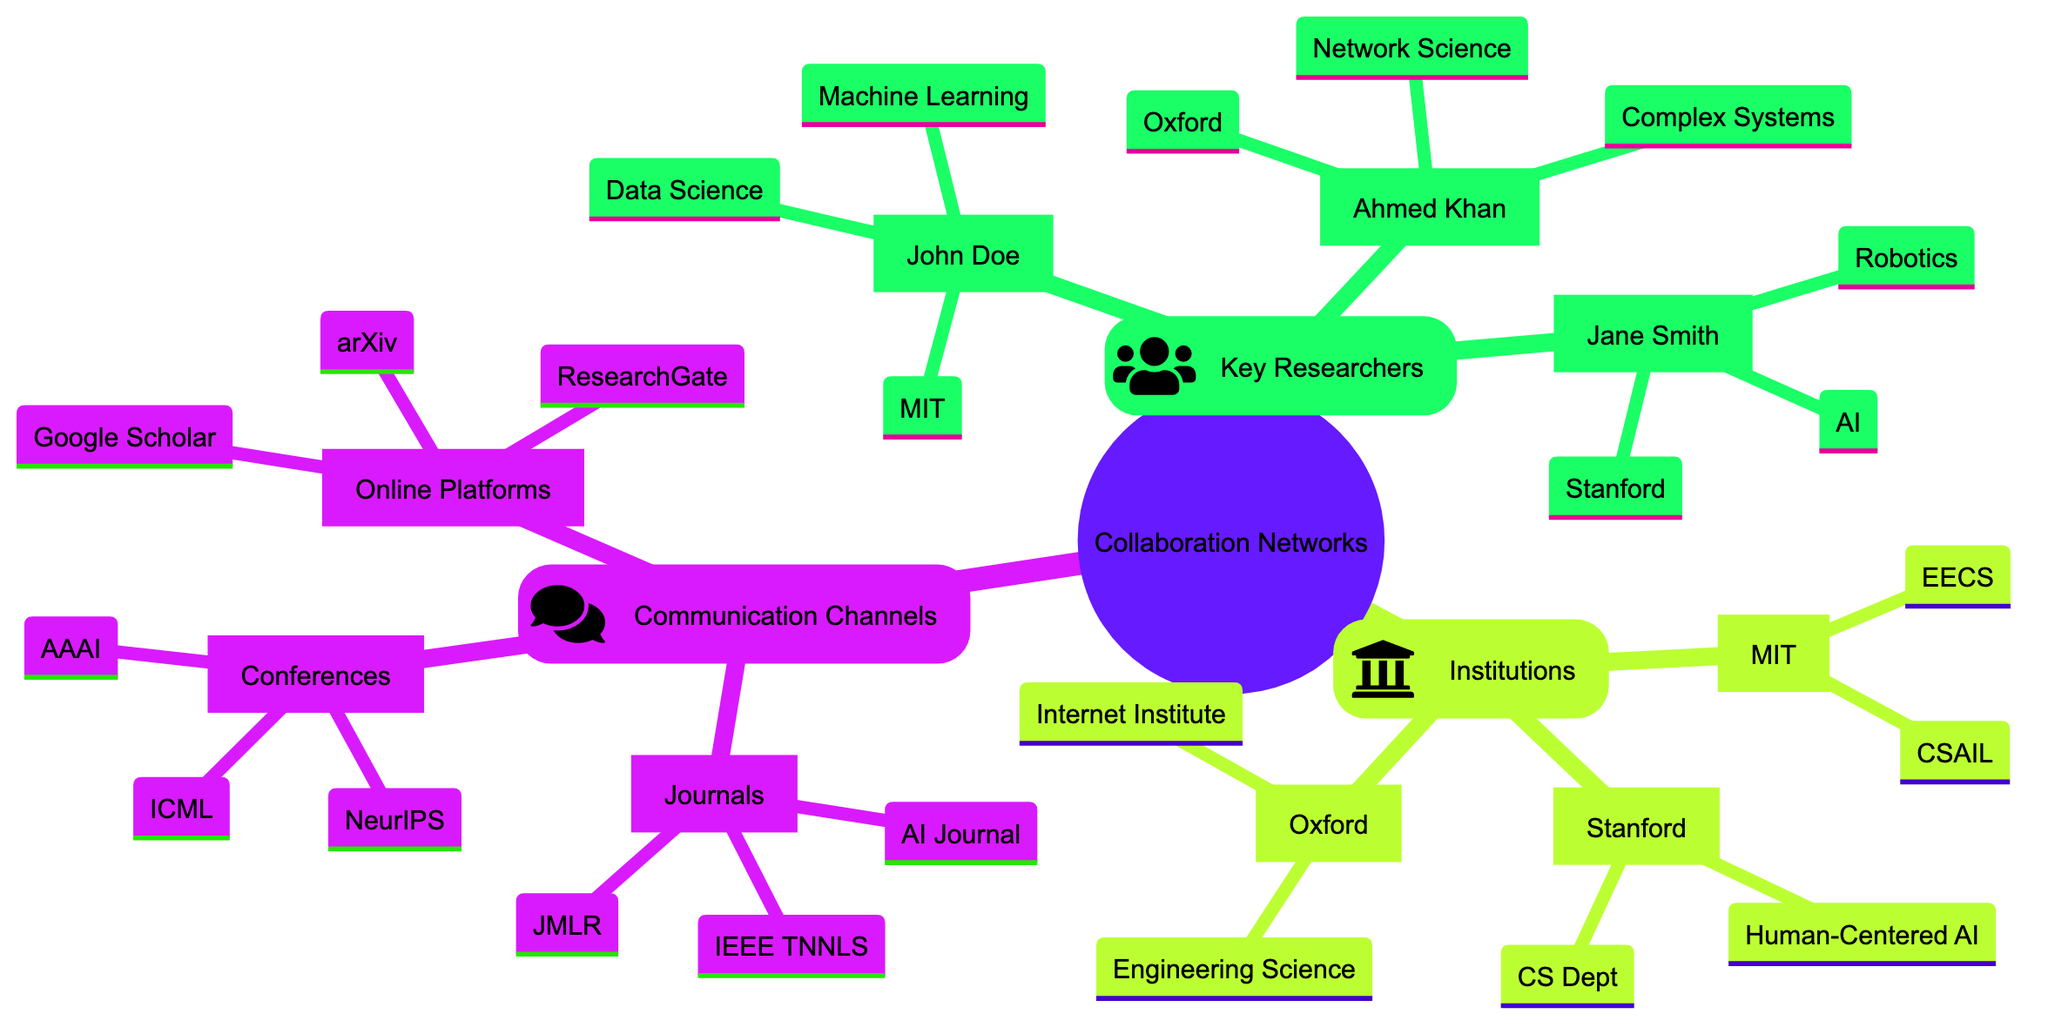What is the institution of John Doe? By looking at the "Key Researchers" section of the diagram, I can see that John Doe is associated with the Massachusetts Institute of Technology, which is listed directly under his name.
Answer: Massachusetts Institute of Technology How many key researchers are listed in the diagram? I can count the names listed under the "Key Researchers" section. There are three names: John Doe, Jane Smith, and Ahmed Khan. Therefore, the total number of key researchers is three.
Answer: 3 What are the research areas of Jane Smith? To find the research areas for Jane Smith, I look under her name in the "Key Researchers" section. It shows "Artificial Intelligence" and "Robotics."
Answer: Artificial Intelligence, Robotics Which institution has departments related to both Computer Science and Artificial Intelligence? By examining the "Institutions" section, I notice the Massachusetts Institute of Technology has the "Computer Science and Artificial Intelligence Laboratory" and the "Department of Electrical Engineering and Computer Science," indicating it covers both areas.
Answer: Massachusetts Institute of Technology What is the purpose of ResearchGate? According to the "Online Platforms" section, ResearchGate is listed alongside its purpose. It specifies "Research Collaboration" as its main purpose.
Answer: Research Collaboration Which conference has a focus on Neural Information Processing? Looking at the "Conferences" section, it is indicated that NeurIPS has a focus on "Machine Learning" and "Neural Information Processing," making it the relevant conference for this topic.
Answer: NeurIPS How many notable projects are associated with Stanford University? To find the number of notable projects associated with Stanford University, I count the projects listed under its name in the "Institutions" section. There are two projects: "Stanford AI Lab" and "Stanford Robotics Lab."
Answer: 2 Which online platform has open access as a key feature? Under the "Online Platforms" section, I find that arXiv is specified to have "Open Access" as a key feature, indicating it allows users to access research freely.
Answer: arXiv What research area does Ahmed Khan specialize in? Examining the "Key Researchers" section, Ahmed Khan is associated with the research areas "Network Science" and "Complex Systems," which are listed near his name.
Answer: Network Science, Complex Systems 